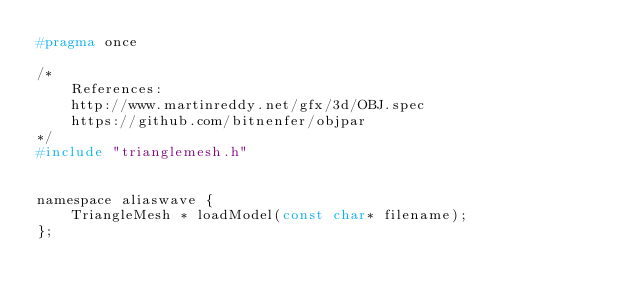<code> <loc_0><loc_0><loc_500><loc_500><_C_>#pragma once

/*
	References:
	http://www.martinreddy.net/gfx/3d/OBJ.spec
	https://github.com/bitnenfer/objpar
*/
#include "trianglemesh.h"


namespace aliaswave {
	TriangleMesh * loadModel(const char* filename);
};</code> 